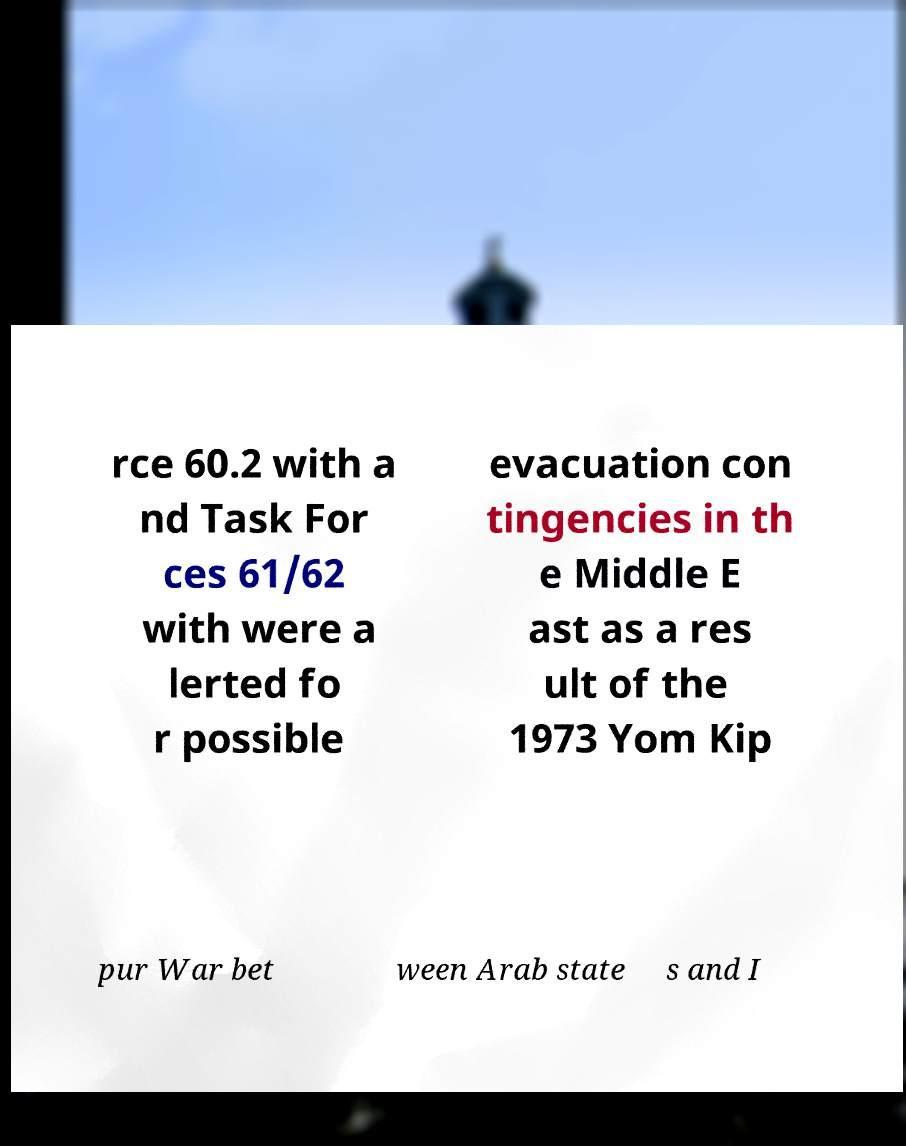I need the written content from this picture converted into text. Can you do that? rce 60.2 with a nd Task For ces 61/62 with were a lerted fo r possible evacuation con tingencies in th e Middle E ast as a res ult of the 1973 Yom Kip pur War bet ween Arab state s and I 